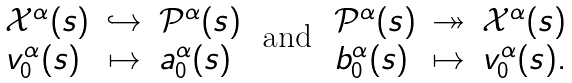<formula> <loc_0><loc_0><loc_500><loc_500>\begin{array} { l c l } \mathcal { X } ^ { \alpha } ( s ) & \hookrightarrow & \mathcal { P } ^ { \alpha } ( s ) \\ v _ { 0 } ^ { \alpha } ( s ) & \mapsto & a _ { 0 } ^ { \alpha } ( s ) \end{array} \, \text { and } \, \begin{array} { l c l } \mathcal { P } ^ { \alpha } ( s ) & \twoheadrightarrow & \mathcal { X } ^ { \alpha } ( s ) \\ b _ { 0 } ^ { \alpha } ( s ) & \mapsto & v _ { 0 } ^ { \alpha } ( s ) . \end{array}</formula> 